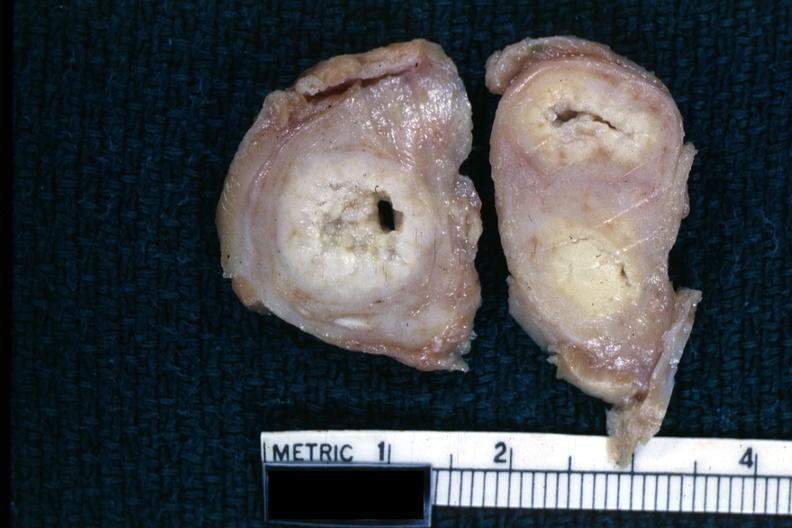does this image show fixed tissue of tuberculosis?
Answer the question using a single word or phrase. Yes 